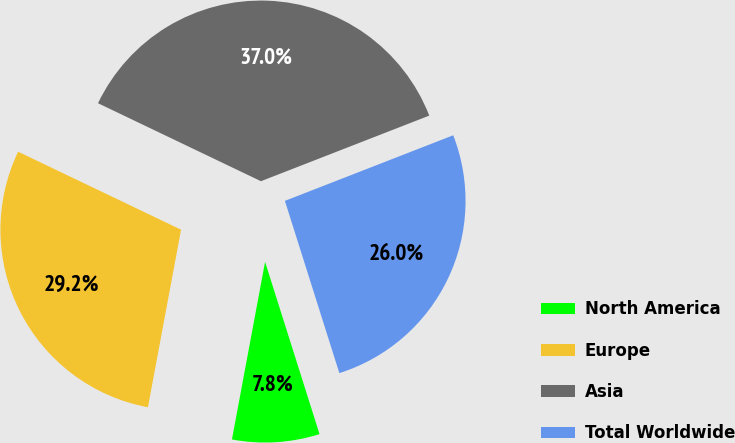Convert chart. <chart><loc_0><loc_0><loc_500><loc_500><pie_chart><fcel>North America<fcel>Europe<fcel>Asia<fcel>Total Worldwide<nl><fcel>7.81%<fcel>29.17%<fcel>36.98%<fcel>26.04%<nl></chart> 